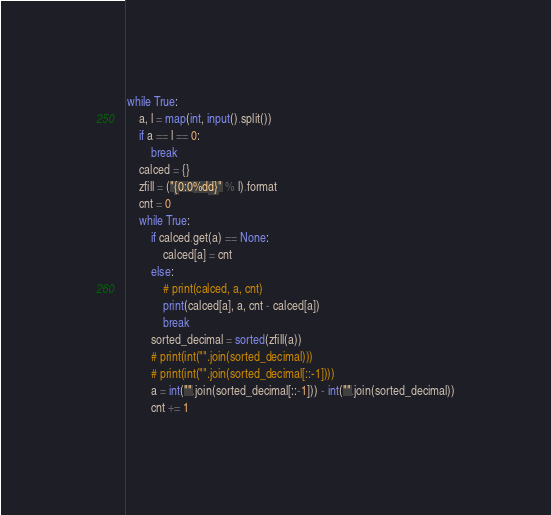<code> <loc_0><loc_0><loc_500><loc_500><_Python_>while True:
    a, l = map(int, input().split())
    if a == l == 0:
        break
    calced = {}
    zfill = ("{0:0%dd}" % l).format
    cnt = 0
    while True:
        if calced.get(a) == None:
            calced[a] = cnt
        else:
            # print(calced, a, cnt)
            print(calced[a], a, cnt - calced[a])
            break
        sorted_decimal = sorted(zfill(a))
        # print(int("".join(sorted_decimal)))
        # print(int("".join(sorted_decimal[::-1])))
        a = int("".join(sorted_decimal[::-1])) - int("".join(sorted_decimal))
        cnt += 1</code> 